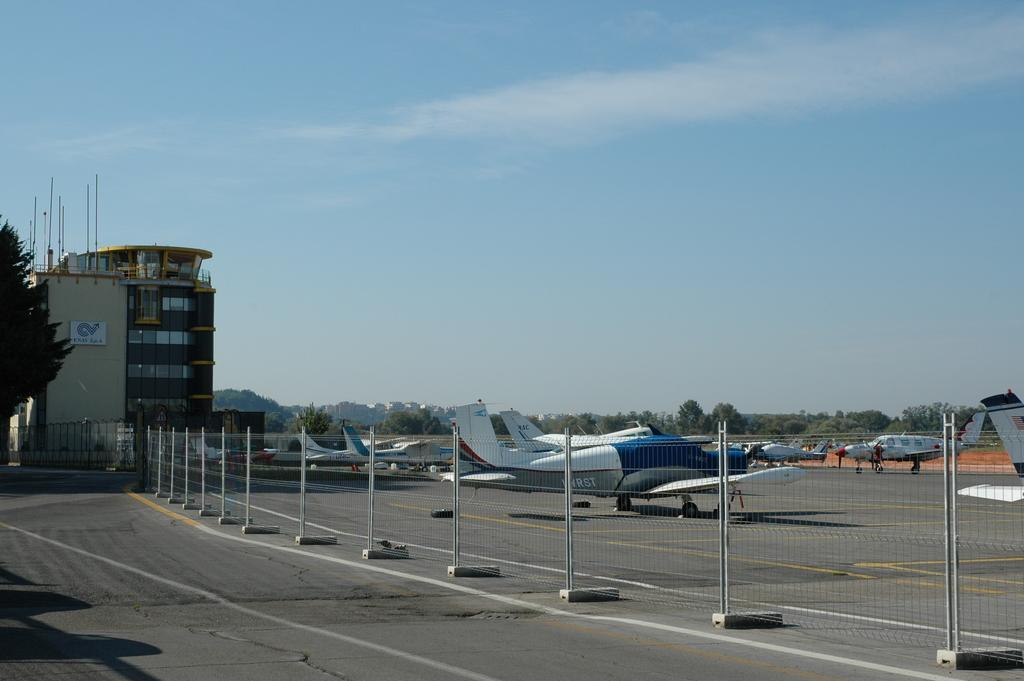What can be seen on the road in the image? There is a fence visible on the road in the image. What is located beside the fence? Flights are present beside the fence. What is on the left side of the image? There is a building and a tree on the left side of the image. What is visible at the top of the image? The sky is visible at the top of the image. How many boats can be seen in the image? There are no boats present in the image. What type of tooth is visible on the tree in the image? There is no tooth present in the image; it features a tree and a building on the left side. 